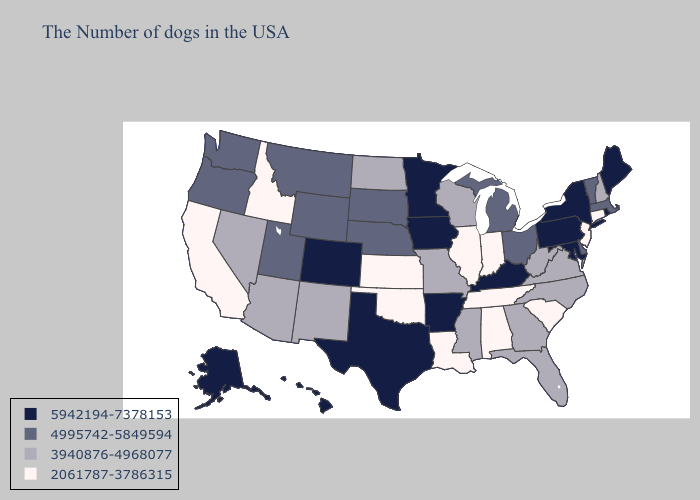Does Illinois have the same value as Kansas?
Short answer required. Yes. Name the states that have a value in the range 5942194-7378153?
Be succinct. Maine, Rhode Island, New York, Maryland, Pennsylvania, Kentucky, Arkansas, Minnesota, Iowa, Texas, Colorado, Alaska, Hawaii. Does Nevada have the highest value in the West?
Keep it brief. No. What is the value of Washington?
Short answer required. 4995742-5849594. Name the states that have a value in the range 3940876-4968077?
Short answer required. New Hampshire, Virginia, North Carolina, West Virginia, Florida, Georgia, Wisconsin, Mississippi, Missouri, North Dakota, New Mexico, Arizona, Nevada. What is the highest value in the West ?
Concise answer only. 5942194-7378153. What is the lowest value in the West?
Write a very short answer. 2061787-3786315. Name the states that have a value in the range 3940876-4968077?
Quick response, please. New Hampshire, Virginia, North Carolina, West Virginia, Florida, Georgia, Wisconsin, Mississippi, Missouri, North Dakota, New Mexico, Arizona, Nevada. What is the value of California?
Quick response, please. 2061787-3786315. Which states have the highest value in the USA?
Concise answer only. Maine, Rhode Island, New York, Maryland, Pennsylvania, Kentucky, Arkansas, Minnesota, Iowa, Texas, Colorado, Alaska, Hawaii. What is the highest value in states that border Michigan?
Write a very short answer. 4995742-5849594. Name the states that have a value in the range 5942194-7378153?
Short answer required. Maine, Rhode Island, New York, Maryland, Pennsylvania, Kentucky, Arkansas, Minnesota, Iowa, Texas, Colorado, Alaska, Hawaii. Name the states that have a value in the range 2061787-3786315?
Short answer required. Connecticut, New Jersey, South Carolina, Indiana, Alabama, Tennessee, Illinois, Louisiana, Kansas, Oklahoma, Idaho, California. Which states hav the highest value in the West?
Concise answer only. Colorado, Alaska, Hawaii. What is the value of Washington?
Answer briefly. 4995742-5849594. 